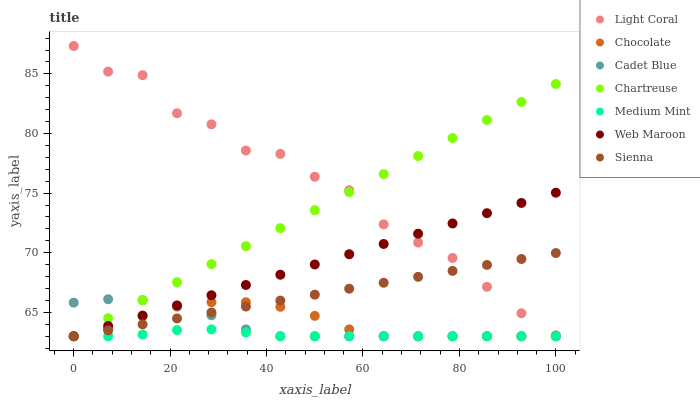Does Medium Mint have the minimum area under the curve?
Answer yes or no. Yes. Does Light Coral have the maximum area under the curve?
Answer yes or no. Yes. Does Sienna have the minimum area under the curve?
Answer yes or no. No. Does Sienna have the maximum area under the curve?
Answer yes or no. No. Is Sienna the smoothest?
Answer yes or no. Yes. Is Light Coral the roughest?
Answer yes or no. Yes. Is Cadet Blue the smoothest?
Answer yes or no. No. Is Cadet Blue the roughest?
Answer yes or no. No. Does Medium Mint have the lowest value?
Answer yes or no. Yes. Does Light Coral have the lowest value?
Answer yes or no. No. Does Light Coral have the highest value?
Answer yes or no. Yes. Does Sienna have the highest value?
Answer yes or no. No. Is Cadet Blue less than Light Coral?
Answer yes or no. Yes. Is Light Coral greater than Chocolate?
Answer yes or no. Yes. Does Chocolate intersect Cadet Blue?
Answer yes or no. Yes. Is Chocolate less than Cadet Blue?
Answer yes or no. No. Is Chocolate greater than Cadet Blue?
Answer yes or no. No. Does Cadet Blue intersect Light Coral?
Answer yes or no. No. 